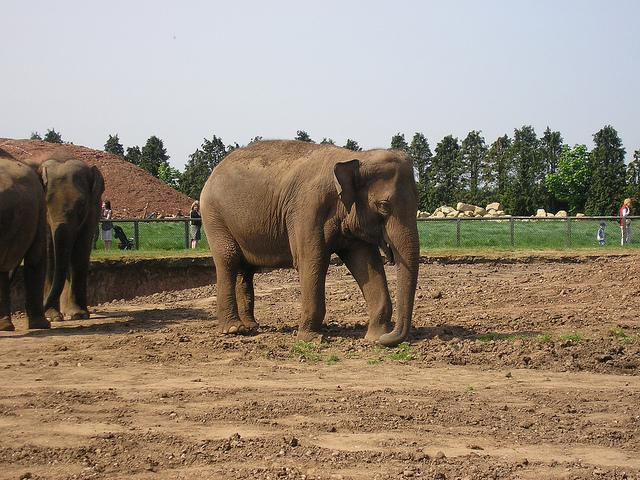Why do people gather outside the fence? Please explain your reasoning. watch elephants. This is the most obvious reason. that said, this location might also offer b. 